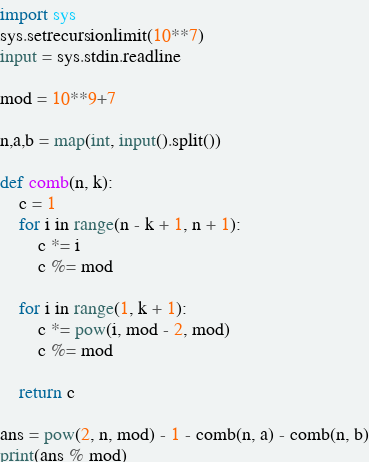Convert code to text. <code><loc_0><loc_0><loc_500><loc_500><_Python_>import sys
sys.setrecursionlimit(10**7)
input = sys.stdin.readline

mod = 10**9+7

n,a,b = map(int, input().split())

def comb(n, k):
    c = 1
    for i in range(n - k + 1, n + 1):
        c *= i
        c %= mod

    for i in range(1, k + 1):
        c *= pow(i, mod - 2, mod)
        c %= mod

    return c

ans = pow(2, n, mod) - 1 - comb(n, a) - comb(n, b)
print(ans % mod)
</code> 